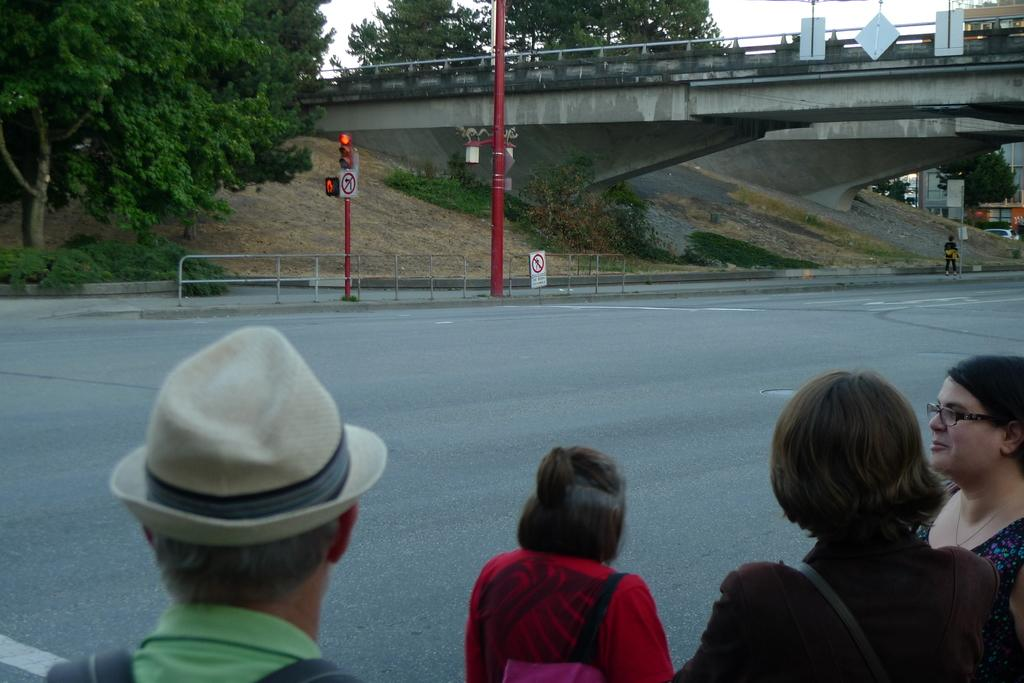What is the main feature of the image? There is a road in the image. What are the people near the road doing? People are standing beside the road. What can be seen in the background of the image? There are poles, trees, a bridge, and the sky visible in the background of the image. What type of berry is being served at the feast in the image? There is no feast or berry present in the image; it features a road with people standing beside it and a background with poles, trees, a bridge, and the sky. 